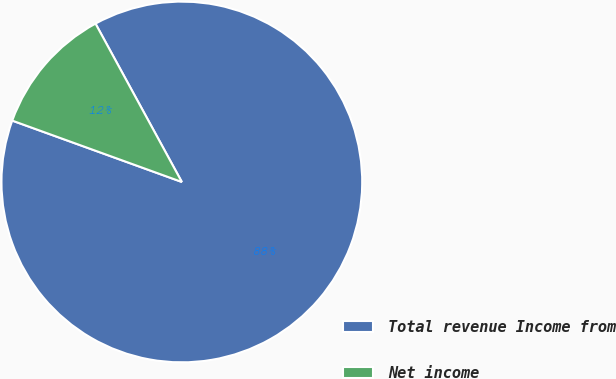<chart> <loc_0><loc_0><loc_500><loc_500><pie_chart><fcel>Total revenue Income from<fcel>Net income<nl><fcel>88.47%<fcel>11.53%<nl></chart> 